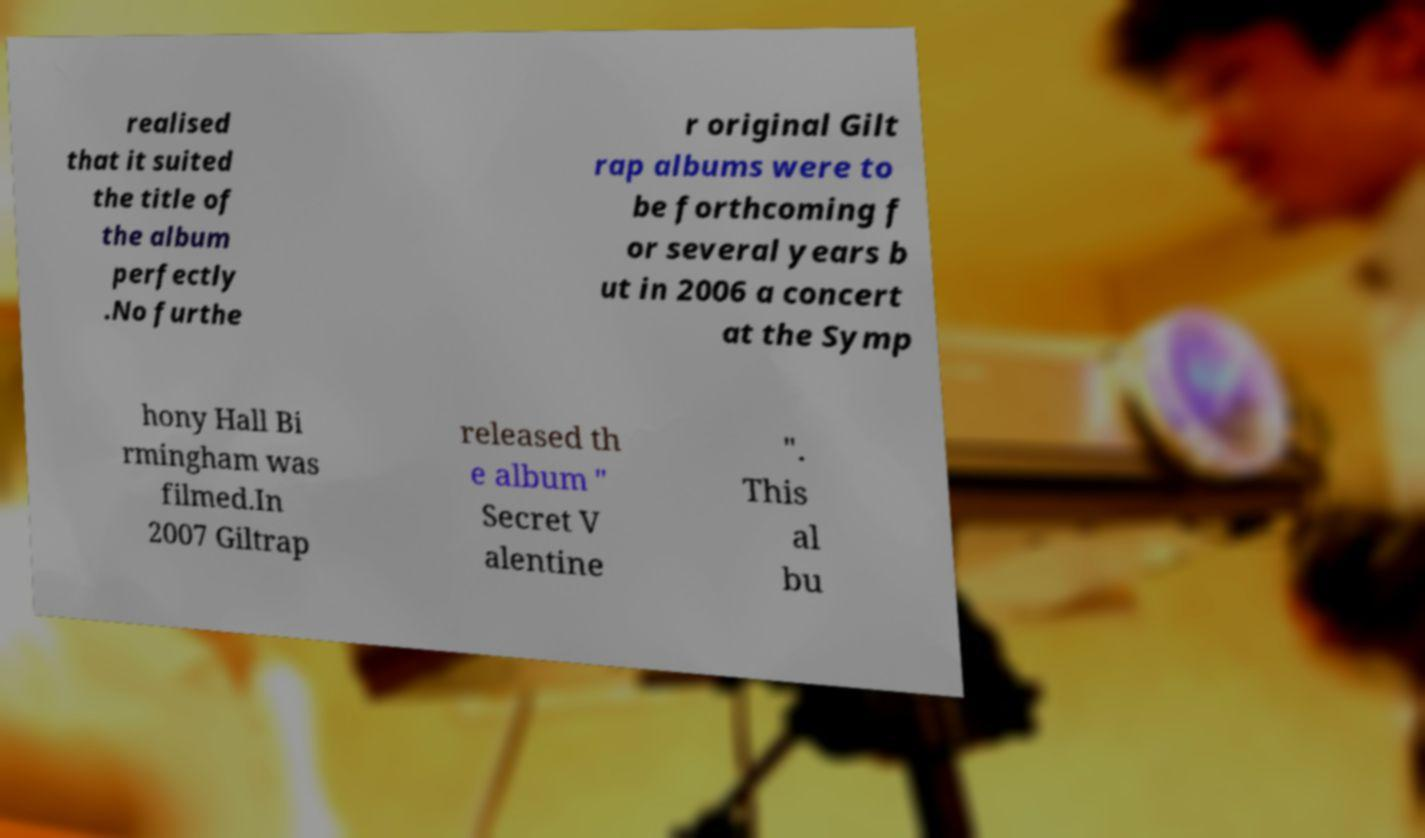Can you accurately transcribe the text from the provided image for me? realised that it suited the title of the album perfectly .No furthe r original Gilt rap albums were to be forthcoming f or several years b ut in 2006 a concert at the Symp hony Hall Bi rmingham was filmed.In 2007 Giltrap released th e album " Secret V alentine ". This al bu 